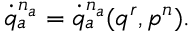<formula> <loc_0><loc_0><loc_500><loc_500>\dot { q } _ { a } ^ { n _ { a } } = \dot { q } _ { a } ^ { n _ { a } } ( q ^ { r } , p ^ { n } ) .</formula> 